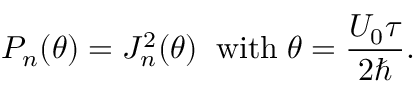<formula> <loc_0><loc_0><loc_500><loc_500>P _ { n } ( \theta ) = J _ { n } ^ { 2 } ( \theta ) \, w i t h \, \theta = \frac { U _ { 0 } \tau } { 2 } .</formula> 